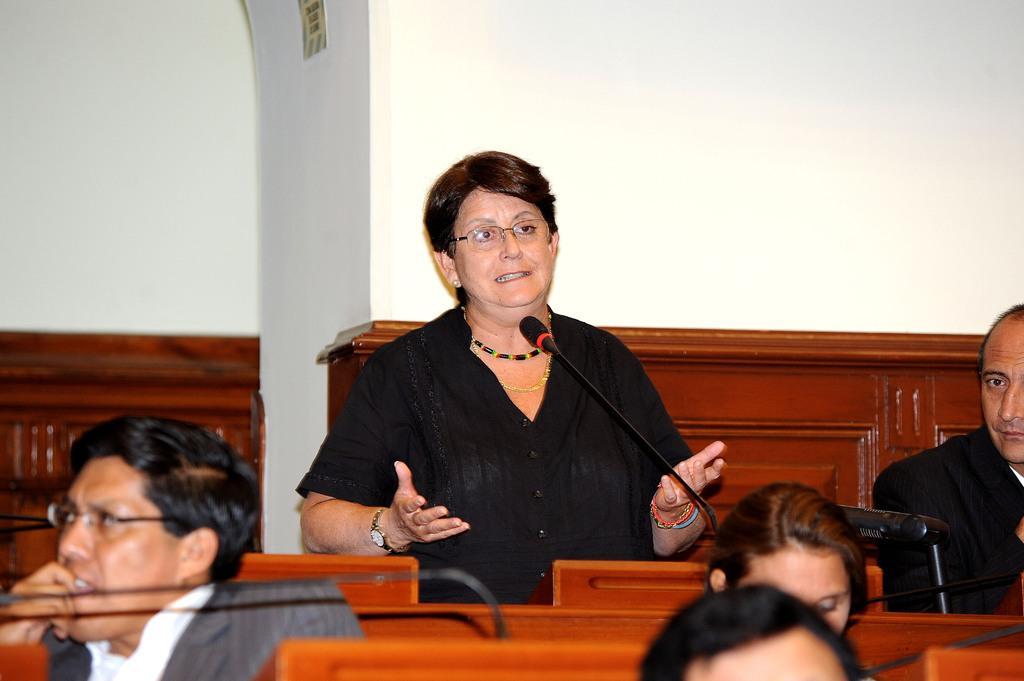Please provide a concise description of this image. In this image there is a woman standing and speaking and there are four more people sitting. In the background there is a plain white wall. Mikes are also visible. 